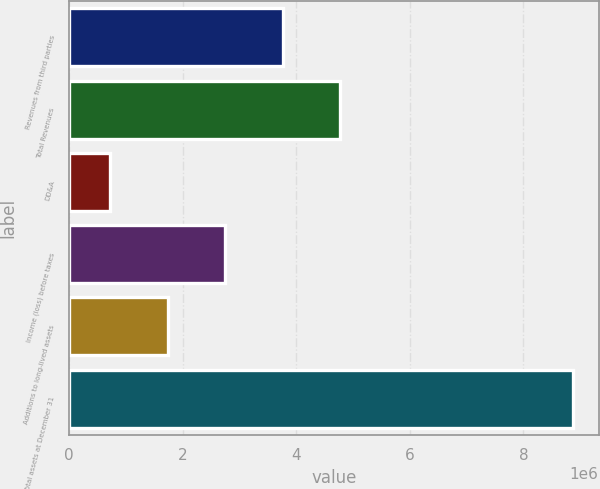Convert chart to OTSL. <chart><loc_0><loc_0><loc_500><loc_500><bar_chart><fcel>Revenues from third parties<fcel>Total Revenues<fcel>DD&A<fcel>Income (loss) before taxes<fcel>Additions to long-lived assets<fcel>Total assets at December 31<nl><fcel>3.75886e+06<fcel>4.76915e+06<fcel>727981<fcel>2.74856e+06<fcel>1.73827e+06<fcel>8.87803e+06<nl></chart> 